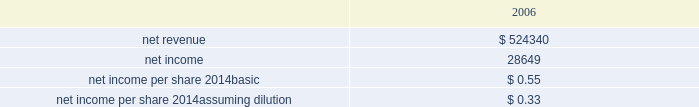Hologic , inc .
Notes to consolidated financial statements ( continued ) ( in thousands , except per share data ) the company has considered the provision of eitf issue no .
95-8 , accounting for contingent consideration paid to the shareholders of and acquired enterprise in a purchase business combination , and concluded that this contingent consideration represents additional purchase price .
During the fourth quarter of fiscal 2007 the company paid approximately $ 19000 to former suros shareholders for the first annual earn-out period resulting in an increase to goodwill for the same amount .
Goodwill will be increased by the amount of the additional consideration , if any , when it becomes due and payable for the second annual earn-out .
In addition to the earn-out discussed above , the company increased goodwill related to the suros acquisition in the amount of $ 210 during the year ended september 29 , 2007 .
The increase was primarily related to recording a liability of approximately $ 550 in accordance with eitf 95-3 related to the termination of certain employees who have ceased all services for the company .
Approximately $ 400 of this liability was paid during the year ended september 29 , 2007 and the balance is expected to be paid by the end of the second quarter of fiscal 2008 .
This increase was partially offset by a decrease to goodwill as a result of a change in the valuation of certain assets and liabilities acquired based on information received during the year ended september 29 , 2007 .
There have been no other material changes to purchase price allocations as disclosed in the company 2019s form 10-k for the year ended september 30 , 2006 .
As part of the purchase price allocation , all intangible assets that were a part of the acquisition were identified and valued .
It was determined that only customer relationship , trade name , developed technology and know how and in-process research and development had separately identifiable values .
Customer relationship represents suros large installed base that are expected to purchase disposable products on a regular basis .
Trade name represent the suros product names that the company intends to continue to use .
Developed technology and know how represents currently marketable purchased products that the company continues to resell as well as utilize to enhance and incorporate into the company 2019s existing products .
The estimated $ 4900 of purchase price allocated to in-process research and development projects primarily related to suros 2019 disposable products .
The projects were at various stages of completion and include next generation handpiece and site marker technologies .
The company has continued to work on these projects and expects they will be completed during fiscal 2008 .
The deferred income tax liability relates to the tax effect of acquired identifiable intangible assets , and fair value adjustments to acquired inventory as such amounts are not deductible for tax purposes , partially offset by acquired net operating loss carry forwards that the company believes are realizable .
For all of the acquisitions discussed above , goodwill represents the excess of the purchase price over the net identifiable tangible and intangible assets acquired .
The company determined that the acquisition of each aeg , biolucent , r2 and suros resulted in the recognition of goodwill primarily because of synergies unique to the company and the strength of its acquired workforce .
Supplemental unaudited pro-forma information the following unaudited pro forma information presents the consolidated results of operations of the company , r2 and suros as if the acquisitions had occurred at the beginning of fiscal 2006 , with pro forma adjustments to give effect to amortization of intangible assets , an increase in interest expense on acquisition financing and certain other adjustments together with related tax effects: .

What would be the net profit margin if the acquisitions occurred at the beginning of fiscal 2006? 
Computations: (28649 / 524340)
Answer: 0.05464. 